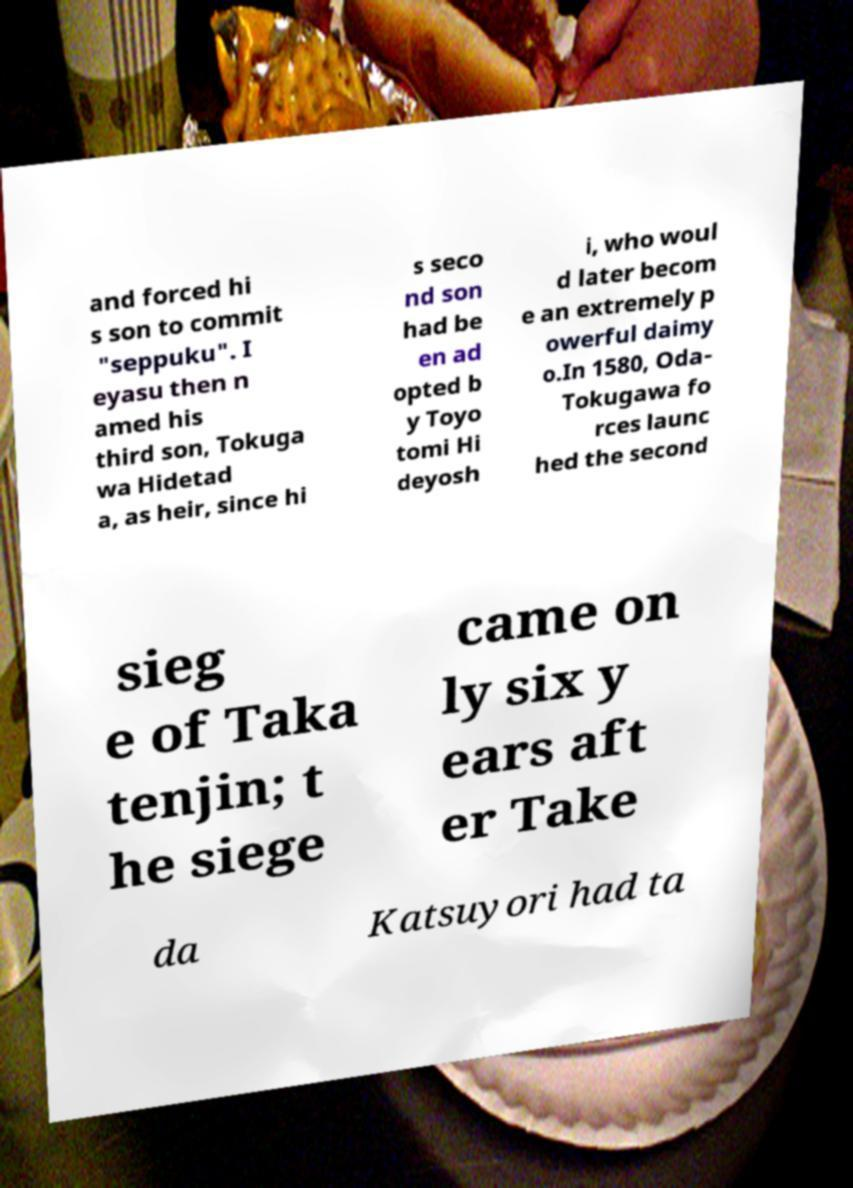Can you read and provide the text displayed in the image?This photo seems to have some interesting text. Can you extract and type it out for me? and forced hi s son to commit "seppuku". I eyasu then n amed his third son, Tokuga wa Hidetad a, as heir, since hi s seco nd son had be en ad opted b y Toyo tomi Hi deyosh i, who woul d later becom e an extremely p owerful daimy o.In 1580, Oda- Tokugawa fo rces launc hed the second sieg e of Taka tenjin; t he siege came on ly six y ears aft er Take da Katsuyori had ta 